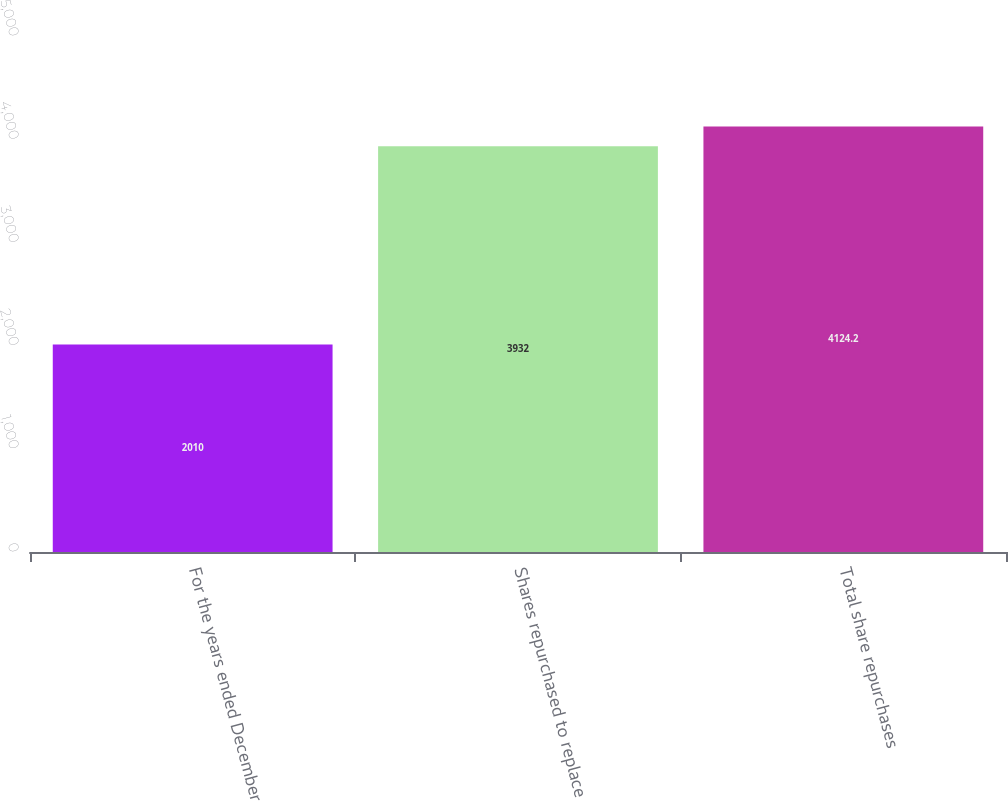Convert chart to OTSL. <chart><loc_0><loc_0><loc_500><loc_500><bar_chart><fcel>For the years ended December<fcel>Shares repurchased to replace<fcel>Total share repurchases<nl><fcel>2010<fcel>3932<fcel>4124.2<nl></chart> 